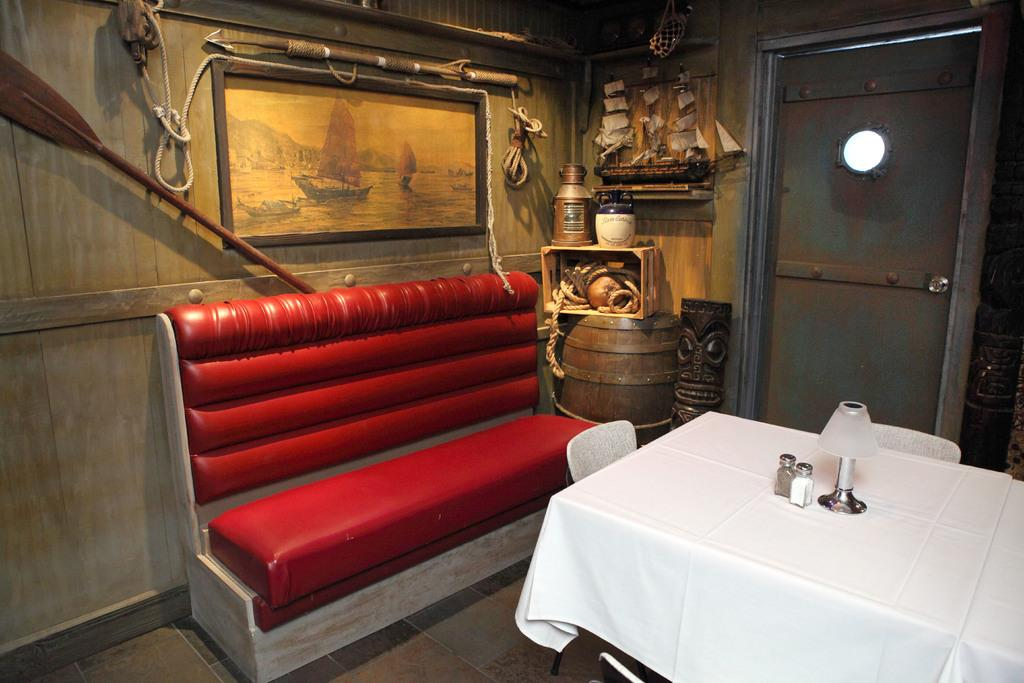Where was the image taken? The image was taken in a room. What furniture is present in the room? There is a sofa, a table, and chairs in the room. Are there any decorative items in the room? Yes, there is a frame in the room. What other objects can be seen in the room? There is a box, a rope, and a ship toy in the room. Can you see a friend playing with a kitten in the image? No, there is no friend or kitten present in the image. What type of shock can be seen in the image? There is no shock present in the image; it is a still image of a room with various objects. 